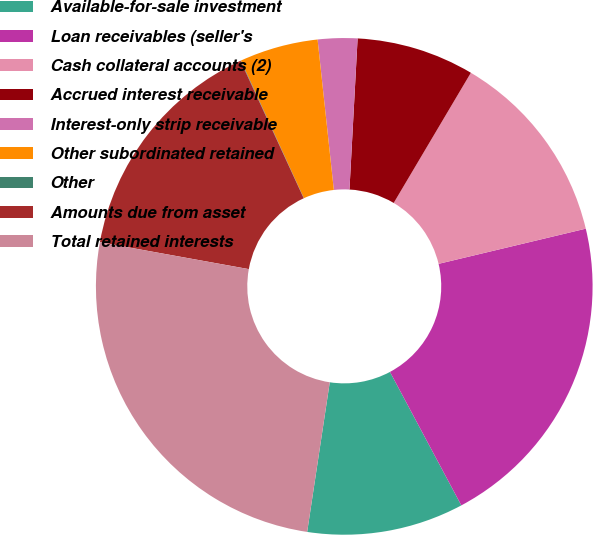<chart> <loc_0><loc_0><loc_500><loc_500><pie_chart><fcel>Available-for-sale investment<fcel>Loan receivables (seller's<fcel>Cash collateral accounts (2)<fcel>Accrued interest receivable<fcel>Interest-only strip receivable<fcel>Other subordinated retained<fcel>Other<fcel>Amounts due from asset<fcel>Total retained interests<nl><fcel>10.2%<fcel>20.92%<fcel>12.75%<fcel>7.66%<fcel>2.57%<fcel>5.12%<fcel>0.03%<fcel>15.29%<fcel>25.46%<nl></chart> 